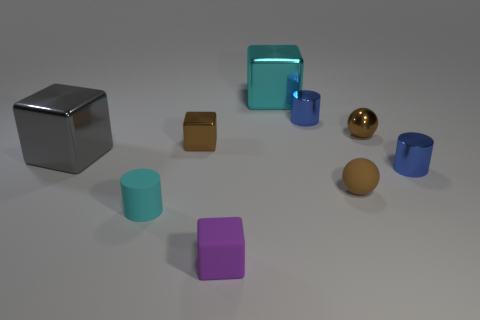Subtract 1 cubes. How many cubes are left? 3 Subtract all balls. How many objects are left? 7 Add 6 gray cubes. How many gray cubes exist? 7 Subtract 0 green balls. How many objects are left? 9 Subtract all gray matte blocks. Subtract all brown matte objects. How many objects are left? 8 Add 1 small rubber things. How many small rubber things are left? 4 